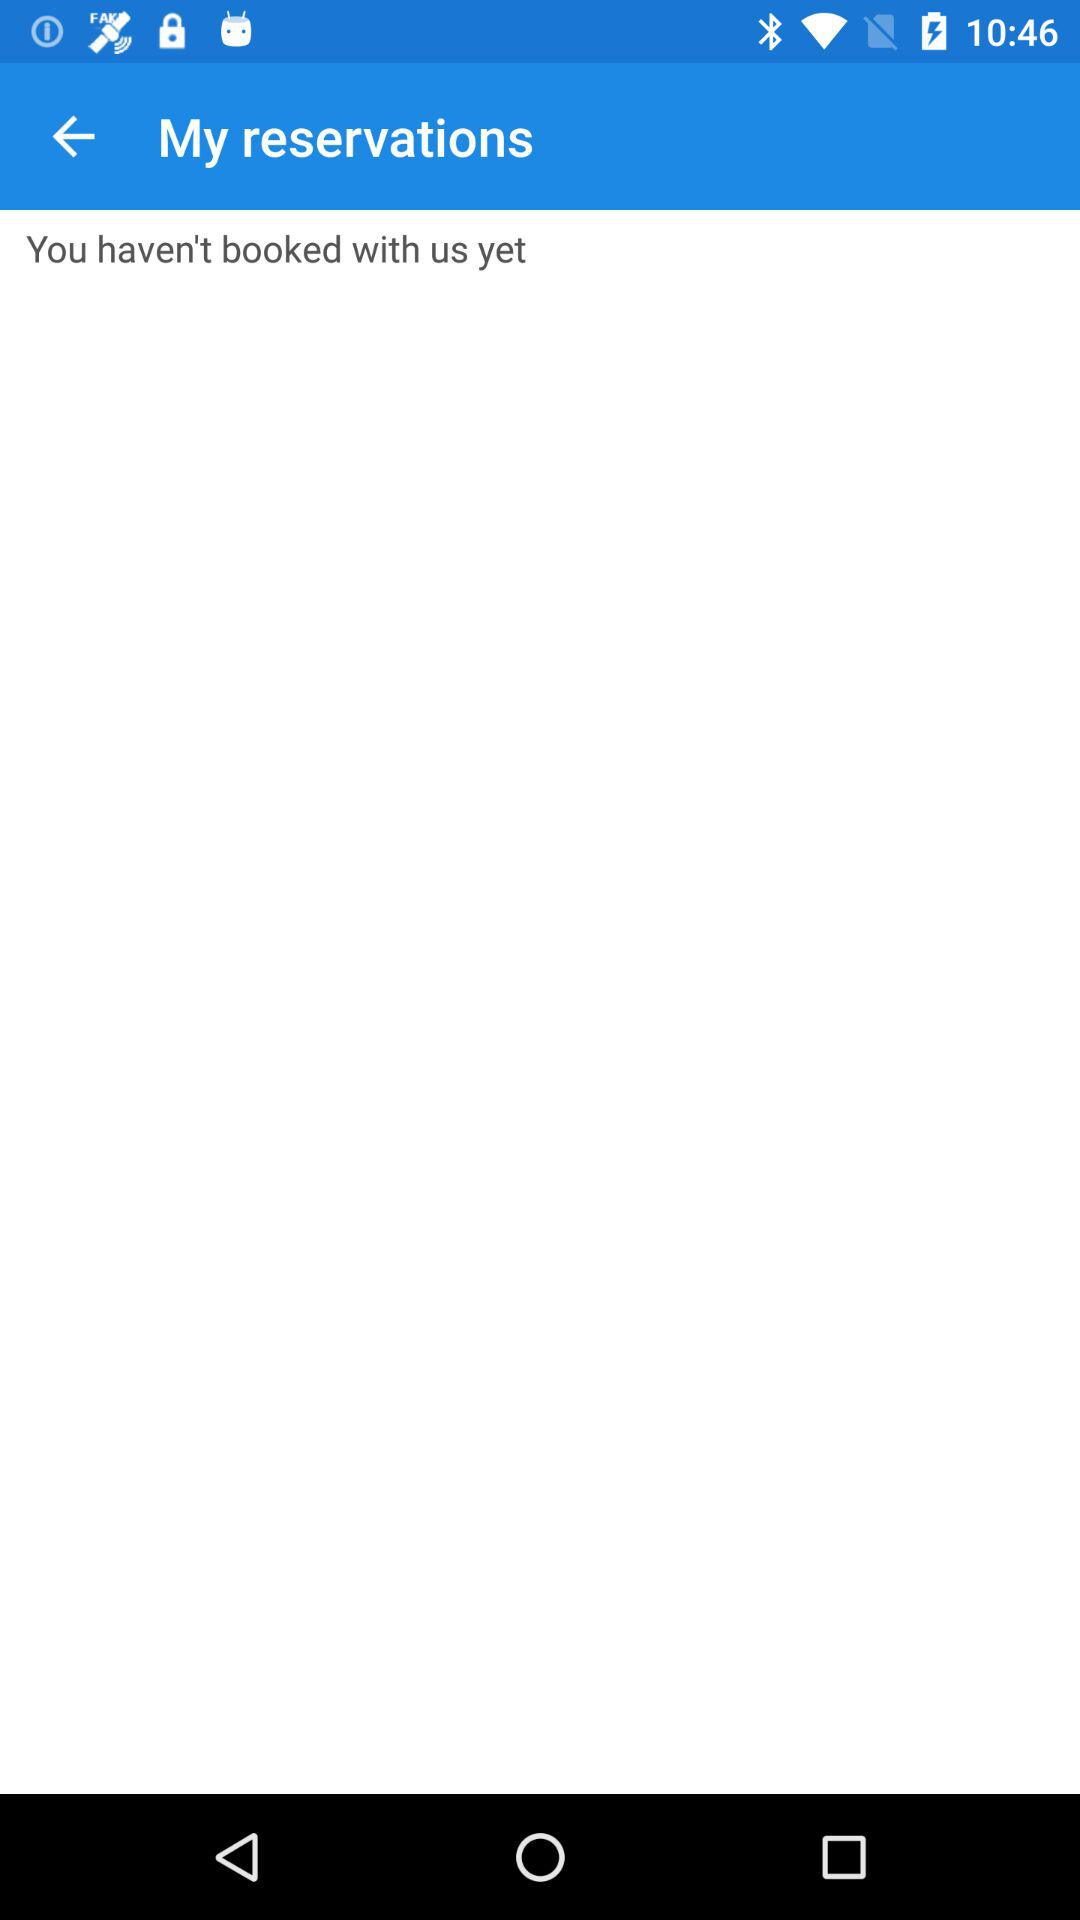Is there any booking? There is no booking. 